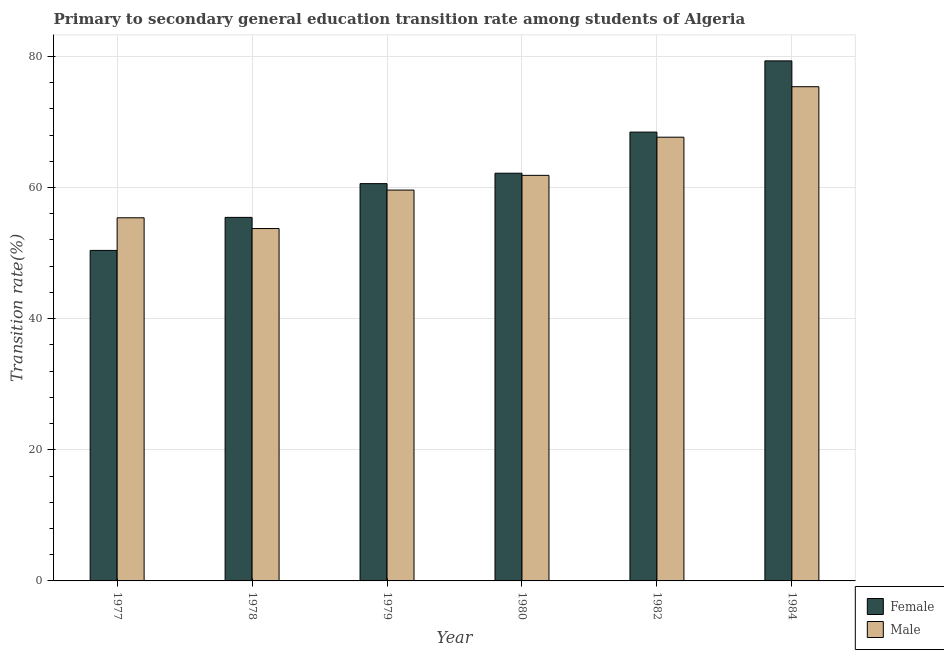How many different coloured bars are there?
Ensure brevity in your answer.  2. How many groups of bars are there?
Ensure brevity in your answer.  6. Are the number of bars per tick equal to the number of legend labels?
Ensure brevity in your answer.  Yes. How many bars are there on the 4th tick from the right?
Provide a succinct answer. 2. What is the label of the 5th group of bars from the left?
Ensure brevity in your answer.  1982. In how many cases, is the number of bars for a given year not equal to the number of legend labels?
Offer a terse response. 0. What is the transition rate among female students in 1979?
Your response must be concise. 60.59. Across all years, what is the maximum transition rate among male students?
Offer a terse response. 75.38. Across all years, what is the minimum transition rate among female students?
Offer a very short reply. 50.41. In which year was the transition rate among female students maximum?
Offer a terse response. 1984. In which year was the transition rate among female students minimum?
Your response must be concise. 1977. What is the total transition rate among female students in the graph?
Offer a terse response. 376.41. What is the difference between the transition rate among male students in 1977 and that in 1979?
Keep it short and to the point. -4.23. What is the difference between the transition rate among female students in 1978 and the transition rate among male students in 1982?
Offer a terse response. -13.01. What is the average transition rate among female students per year?
Offer a very short reply. 62.73. What is the ratio of the transition rate among male students in 1978 to that in 1984?
Offer a very short reply. 0.71. Is the transition rate among female students in 1977 less than that in 1982?
Your answer should be compact. Yes. Is the difference between the transition rate among male students in 1977 and 1978 greater than the difference between the transition rate among female students in 1977 and 1978?
Keep it short and to the point. No. What is the difference between the highest and the second highest transition rate among female students?
Your answer should be compact. 10.86. What is the difference between the highest and the lowest transition rate among male students?
Ensure brevity in your answer.  21.63. In how many years, is the transition rate among male students greater than the average transition rate among male students taken over all years?
Your answer should be very brief. 2. Is the sum of the transition rate among female students in 1978 and 1984 greater than the maximum transition rate among male students across all years?
Make the answer very short. Yes. What does the 1st bar from the left in 1984 represents?
Ensure brevity in your answer.  Female. What does the 1st bar from the right in 1978 represents?
Your response must be concise. Male. How many bars are there?
Give a very brief answer. 12. What is the difference between two consecutive major ticks on the Y-axis?
Provide a short and direct response. 20. What is the title of the graph?
Offer a very short reply. Primary to secondary general education transition rate among students of Algeria. Does "Investments" appear as one of the legend labels in the graph?
Ensure brevity in your answer.  No. What is the label or title of the Y-axis?
Your response must be concise. Transition rate(%). What is the Transition rate(%) in Female in 1977?
Provide a short and direct response. 50.41. What is the Transition rate(%) of Male in 1977?
Provide a succinct answer. 55.39. What is the Transition rate(%) in Female in 1978?
Offer a terse response. 55.45. What is the Transition rate(%) in Male in 1978?
Your answer should be very brief. 53.75. What is the Transition rate(%) in Female in 1979?
Offer a very short reply. 60.59. What is the Transition rate(%) in Male in 1979?
Ensure brevity in your answer.  59.61. What is the Transition rate(%) in Female in 1980?
Provide a succinct answer. 62.18. What is the Transition rate(%) of Male in 1980?
Offer a very short reply. 61.86. What is the Transition rate(%) of Female in 1982?
Provide a short and direct response. 68.46. What is the Transition rate(%) of Male in 1982?
Provide a short and direct response. 67.68. What is the Transition rate(%) of Female in 1984?
Offer a very short reply. 79.32. What is the Transition rate(%) of Male in 1984?
Make the answer very short. 75.38. Across all years, what is the maximum Transition rate(%) of Female?
Give a very brief answer. 79.32. Across all years, what is the maximum Transition rate(%) of Male?
Keep it short and to the point. 75.38. Across all years, what is the minimum Transition rate(%) of Female?
Provide a short and direct response. 50.41. Across all years, what is the minimum Transition rate(%) in Male?
Your answer should be compact. 53.75. What is the total Transition rate(%) in Female in the graph?
Offer a very short reply. 376.41. What is the total Transition rate(%) in Male in the graph?
Your answer should be compact. 373.66. What is the difference between the Transition rate(%) in Female in 1977 and that in 1978?
Make the answer very short. -5.04. What is the difference between the Transition rate(%) of Male in 1977 and that in 1978?
Ensure brevity in your answer.  1.64. What is the difference between the Transition rate(%) of Female in 1977 and that in 1979?
Keep it short and to the point. -10.18. What is the difference between the Transition rate(%) in Male in 1977 and that in 1979?
Your response must be concise. -4.23. What is the difference between the Transition rate(%) in Female in 1977 and that in 1980?
Offer a terse response. -11.77. What is the difference between the Transition rate(%) of Male in 1977 and that in 1980?
Offer a very short reply. -6.47. What is the difference between the Transition rate(%) of Female in 1977 and that in 1982?
Make the answer very short. -18.04. What is the difference between the Transition rate(%) in Male in 1977 and that in 1982?
Make the answer very short. -12.29. What is the difference between the Transition rate(%) of Female in 1977 and that in 1984?
Your response must be concise. -28.91. What is the difference between the Transition rate(%) of Male in 1977 and that in 1984?
Provide a succinct answer. -19.99. What is the difference between the Transition rate(%) in Female in 1978 and that in 1979?
Your answer should be compact. -5.15. What is the difference between the Transition rate(%) in Male in 1978 and that in 1979?
Make the answer very short. -5.87. What is the difference between the Transition rate(%) in Female in 1978 and that in 1980?
Offer a terse response. -6.74. What is the difference between the Transition rate(%) in Male in 1978 and that in 1980?
Your answer should be very brief. -8.11. What is the difference between the Transition rate(%) in Female in 1978 and that in 1982?
Your answer should be very brief. -13.01. What is the difference between the Transition rate(%) of Male in 1978 and that in 1982?
Your response must be concise. -13.93. What is the difference between the Transition rate(%) of Female in 1978 and that in 1984?
Your response must be concise. -23.87. What is the difference between the Transition rate(%) in Male in 1978 and that in 1984?
Give a very brief answer. -21.63. What is the difference between the Transition rate(%) of Female in 1979 and that in 1980?
Provide a succinct answer. -1.59. What is the difference between the Transition rate(%) of Male in 1979 and that in 1980?
Your response must be concise. -2.24. What is the difference between the Transition rate(%) in Female in 1979 and that in 1982?
Your answer should be very brief. -7.86. What is the difference between the Transition rate(%) of Male in 1979 and that in 1982?
Provide a short and direct response. -8.06. What is the difference between the Transition rate(%) of Female in 1979 and that in 1984?
Provide a short and direct response. -18.72. What is the difference between the Transition rate(%) of Male in 1979 and that in 1984?
Keep it short and to the point. -15.77. What is the difference between the Transition rate(%) of Female in 1980 and that in 1982?
Your answer should be very brief. -6.27. What is the difference between the Transition rate(%) of Male in 1980 and that in 1982?
Provide a succinct answer. -5.82. What is the difference between the Transition rate(%) of Female in 1980 and that in 1984?
Give a very brief answer. -17.13. What is the difference between the Transition rate(%) in Male in 1980 and that in 1984?
Your response must be concise. -13.52. What is the difference between the Transition rate(%) in Female in 1982 and that in 1984?
Your response must be concise. -10.86. What is the difference between the Transition rate(%) in Male in 1982 and that in 1984?
Provide a short and direct response. -7.7. What is the difference between the Transition rate(%) in Female in 1977 and the Transition rate(%) in Male in 1978?
Your response must be concise. -3.34. What is the difference between the Transition rate(%) of Female in 1977 and the Transition rate(%) of Male in 1979?
Ensure brevity in your answer.  -9.2. What is the difference between the Transition rate(%) of Female in 1977 and the Transition rate(%) of Male in 1980?
Offer a very short reply. -11.45. What is the difference between the Transition rate(%) of Female in 1977 and the Transition rate(%) of Male in 1982?
Give a very brief answer. -17.27. What is the difference between the Transition rate(%) of Female in 1977 and the Transition rate(%) of Male in 1984?
Offer a very short reply. -24.97. What is the difference between the Transition rate(%) of Female in 1978 and the Transition rate(%) of Male in 1979?
Make the answer very short. -4.17. What is the difference between the Transition rate(%) in Female in 1978 and the Transition rate(%) in Male in 1980?
Provide a short and direct response. -6.41. What is the difference between the Transition rate(%) in Female in 1978 and the Transition rate(%) in Male in 1982?
Your answer should be compact. -12.23. What is the difference between the Transition rate(%) in Female in 1978 and the Transition rate(%) in Male in 1984?
Offer a terse response. -19.93. What is the difference between the Transition rate(%) of Female in 1979 and the Transition rate(%) of Male in 1980?
Provide a succinct answer. -1.26. What is the difference between the Transition rate(%) of Female in 1979 and the Transition rate(%) of Male in 1982?
Give a very brief answer. -7.08. What is the difference between the Transition rate(%) in Female in 1979 and the Transition rate(%) in Male in 1984?
Offer a terse response. -14.78. What is the difference between the Transition rate(%) of Female in 1980 and the Transition rate(%) of Male in 1982?
Provide a succinct answer. -5.49. What is the difference between the Transition rate(%) of Female in 1980 and the Transition rate(%) of Male in 1984?
Your response must be concise. -13.19. What is the difference between the Transition rate(%) in Female in 1982 and the Transition rate(%) in Male in 1984?
Ensure brevity in your answer.  -6.92. What is the average Transition rate(%) of Female per year?
Keep it short and to the point. 62.73. What is the average Transition rate(%) in Male per year?
Ensure brevity in your answer.  62.28. In the year 1977, what is the difference between the Transition rate(%) of Female and Transition rate(%) of Male?
Offer a terse response. -4.98. In the year 1978, what is the difference between the Transition rate(%) in Female and Transition rate(%) in Male?
Your answer should be compact. 1.7. In the year 1979, what is the difference between the Transition rate(%) in Female and Transition rate(%) in Male?
Your response must be concise. 0.98. In the year 1980, what is the difference between the Transition rate(%) in Female and Transition rate(%) in Male?
Your answer should be compact. 0.33. In the year 1982, what is the difference between the Transition rate(%) in Female and Transition rate(%) in Male?
Your answer should be very brief. 0.78. In the year 1984, what is the difference between the Transition rate(%) in Female and Transition rate(%) in Male?
Offer a terse response. 3.94. What is the ratio of the Transition rate(%) in Female in 1977 to that in 1978?
Offer a terse response. 0.91. What is the ratio of the Transition rate(%) in Male in 1977 to that in 1978?
Ensure brevity in your answer.  1.03. What is the ratio of the Transition rate(%) in Female in 1977 to that in 1979?
Your answer should be very brief. 0.83. What is the ratio of the Transition rate(%) of Male in 1977 to that in 1979?
Provide a succinct answer. 0.93. What is the ratio of the Transition rate(%) of Female in 1977 to that in 1980?
Provide a succinct answer. 0.81. What is the ratio of the Transition rate(%) of Male in 1977 to that in 1980?
Your answer should be very brief. 0.9. What is the ratio of the Transition rate(%) in Female in 1977 to that in 1982?
Your response must be concise. 0.74. What is the ratio of the Transition rate(%) of Male in 1977 to that in 1982?
Your response must be concise. 0.82. What is the ratio of the Transition rate(%) in Female in 1977 to that in 1984?
Offer a very short reply. 0.64. What is the ratio of the Transition rate(%) of Male in 1977 to that in 1984?
Your answer should be compact. 0.73. What is the ratio of the Transition rate(%) of Female in 1978 to that in 1979?
Offer a very short reply. 0.92. What is the ratio of the Transition rate(%) in Male in 1978 to that in 1979?
Offer a very short reply. 0.9. What is the ratio of the Transition rate(%) of Female in 1978 to that in 1980?
Offer a very short reply. 0.89. What is the ratio of the Transition rate(%) of Male in 1978 to that in 1980?
Keep it short and to the point. 0.87. What is the ratio of the Transition rate(%) of Female in 1978 to that in 1982?
Offer a very short reply. 0.81. What is the ratio of the Transition rate(%) in Male in 1978 to that in 1982?
Your answer should be very brief. 0.79. What is the ratio of the Transition rate(%) in Female in 1978 to that in 1984?
Your response must be concise. 0.7. What is the ratio of the Transition rate(%) of Male in 1978 to that in 1984?
Offer a very short reply. 0.71. What is the ratio of the Transition rate(%) in Female in 1979 to that in 1980?
Ensure brevity in your answer.  0.97. What is the ratio of the Transition rate(%) of Male in 1979 to that in 1980?
Your answer should be very brief. 0.96. What is the ratio of the Transition rate(%) of Female in 1979 to that in 1982?
Make the answer very short. 0.89. What is the ratio of the Transition rate(%) in Male in 1979 to that in 1982?
Provide a short and direct response. 0.88. What is the ratio of the Transition rate(%) in Female in 1979 to that in 1984?
Give a very brief answer. 0.76. What is the ratio of the Transition rate(%) in Male in 1979 to that in 1984?
Offer a very short reply. 0.79. What is the ratio of the Transition rate(%) in Female in 1980 to that in 1982?
Make the answer very short. 0.91. What is the ratio of the Transition rate(%) of Male in 1980 to that in 1982?
Make the answer very short. 0.91. What is the ratio of the Transition rate(%) of Female in 1980 to that in 1984?
Ensure brevity in your answer.  0.78. What is the ratio of the Transition rate(%) of Male in 1980 to that in 1984?
Make the answer very short. 0.82. What is the ratio of the Transition rate(%) of Female in 1982 to that in 1984?
Provide a succinct answer. 0.86. What is the ratio of the Transition rate(%) in Male in 1982 to that in 1984?
Offer a terse response. 0.9. What is the difference between the highest and the second highest Transition rate(%) in Female?
Your response must be concise. 10.86. What is the difference between the highest and the second highest Transition rate(%) of Male?
Give a very brief answer. 7.7. What is the difference between the highest and the lowest Transition rate(%) of Female?
Make the answer very short. 28.91. What is the difference between the highest and the lowest Transition rate(%) of Male?
Provide a succinct answer. 21.63. 